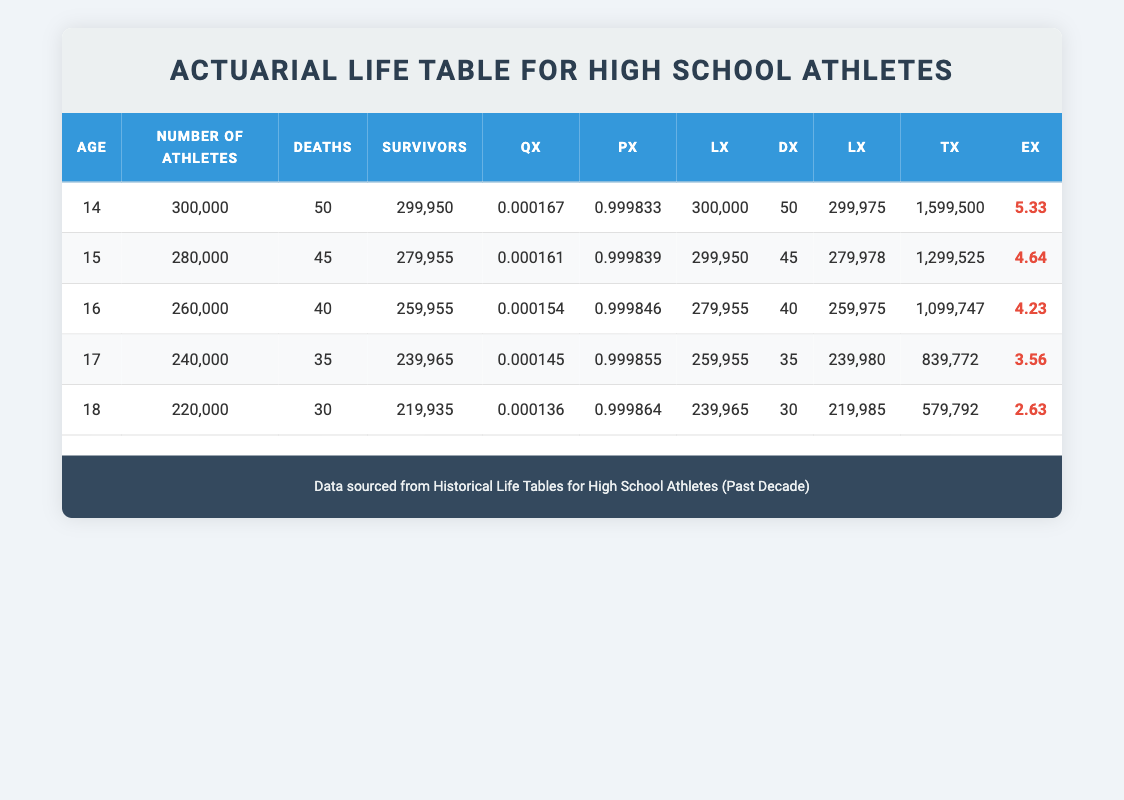What is the number of athletes at age 16? The table lists the number of athletes for each age group. For age 16, it specifically states the number of athletes is 260,000.
Answer: 260,000 What is the death rate (qx) for 18-year-old athletes? In the table, the death rate (qx) for 18-year-old athletes is found in the corresponding column. For age 18, qx is 0.000136.
Answer: 0.000136 How many athletes survived from ages 14 to 18? To find the total number of survivors from ages 14 to 18, we'll sum the survivors from each age: 299,950 + 279,955 + 259,955 + 239,965 + 219,935 = 1,279,960.
Answer: 1,279,960 Is the average life expectancy (ex) at age 17 higher or lower than at age 15? For age 17, the life expectancy (ex) is 3.56 and for age 15 it is 4.64. Since 3.56 is lower than 4.64, the average life expectancy at age 17 is lower than at age 15.
Answer: Lower What is the total number of deaths for athletes aged 14 to 18? The total number of deaths can be computed by summing the deaths from each age group: 50 + 45 + 40 + 35 + 30 = 200.
Answer: 200 At which age is the highest number of athletes recorded? By comparing the "Number of Athletes" column, 14 years old shows the highest at 300,000.
Answer: 14 What is the difference in number of athletes between ages 14 and 17? To find the difference, subtract the number of athletes at age 17 from that at age 14: 300,000 - 240,000 = 60,000.
Answer: 60,000 Are there more survivors at age 16 than at age 18? From the survivors' column, age 16 has 259,955 survivors and age 18 has 219,935 survivors. Since 259,955 is greater than 219,935, the statement is true.
Answer: Yes What is the percentage of deaths at age 15? To determine the percentage of deaths at age 15, we calculate: (45 deaths / 280,000 athletes) * 100 = 0.0161%, which rounds to approximately 0.016%.
Answer: 0.016% 